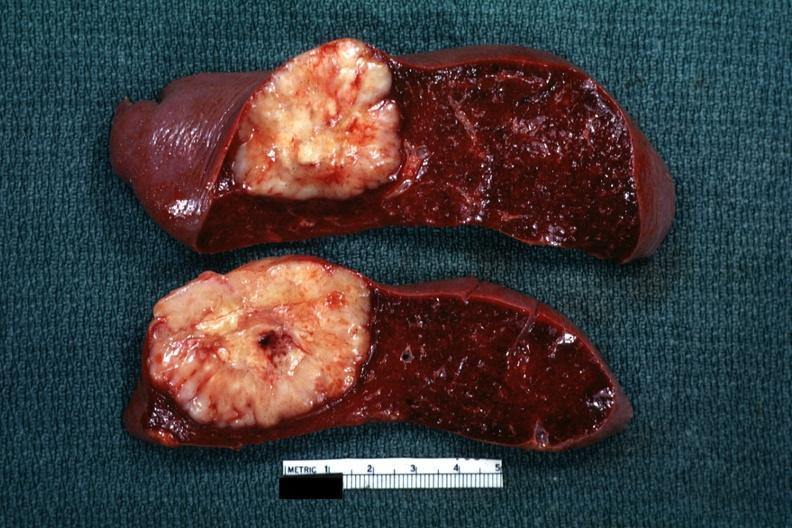what is present?
Answer the question using a single word or phrase. Hematologic 